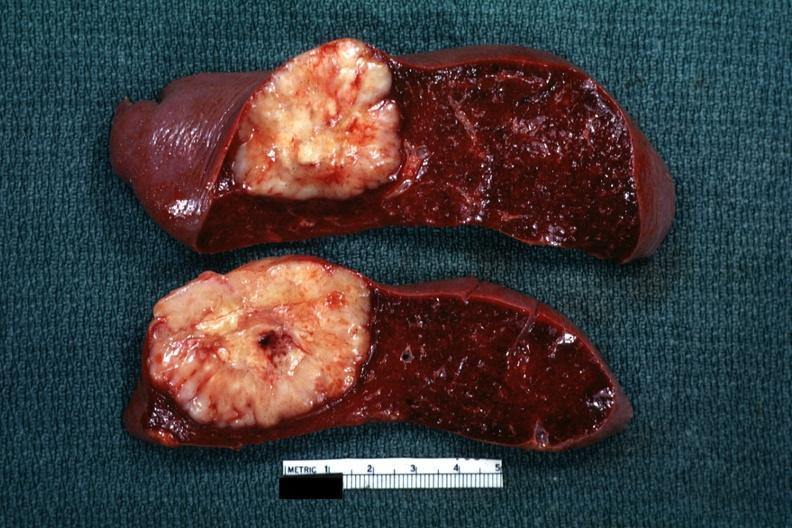what is present?
Answer the question using a single word or phrase. Hematologic 